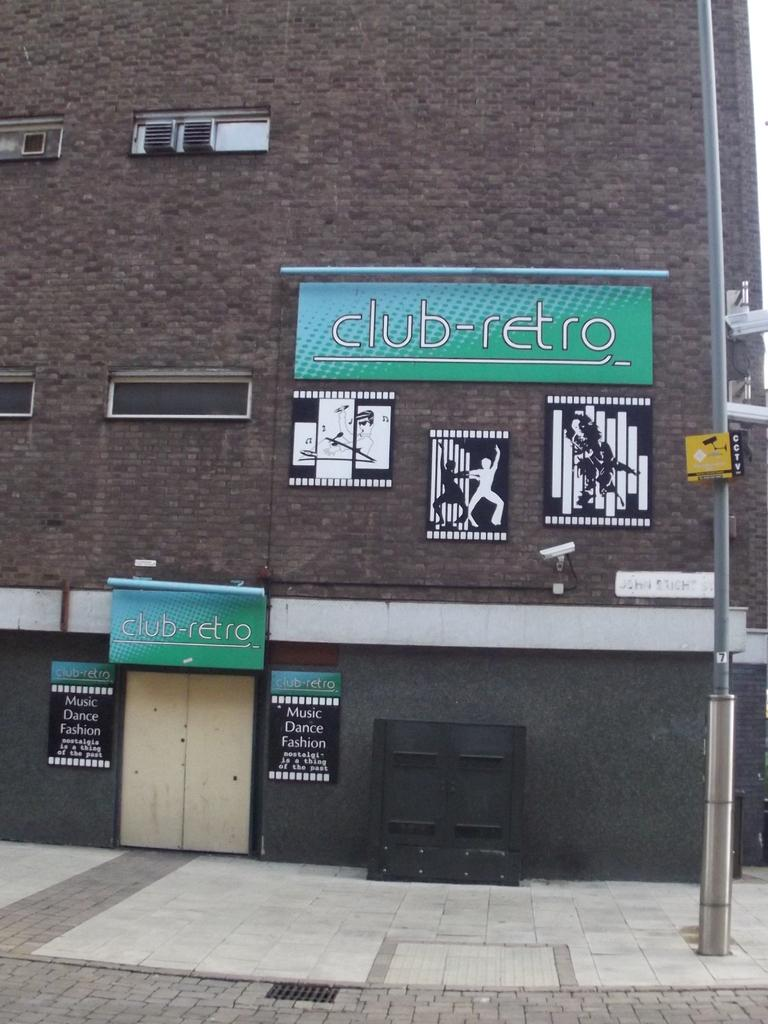What structure is located on the right side of the image? There is a light pole on the right side of the image. What type of openings can be seen in the image? There are ventilation windows in the image. What type of signage is present on the wall in the image? There are hoardings on the wall in the image. What type of pathway is visible in the image? There is a walkway in the image. What type of entrance is present in the image? There is a door in the image. Where is the mailbox located in the image? There is no mailbox present in the image. What type of insurance is advertised on the hoardings in the image? There is no insurance information on the hoardings in the image. 